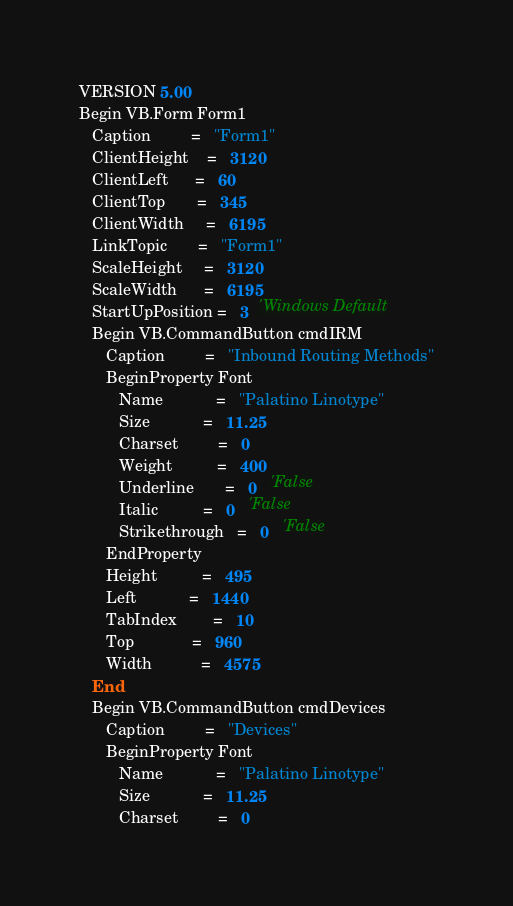<code> <loc_0><loc_0><loc_500><loc_500><_VisualBasic_>VERSION 5.00
Begin VB.Form Form1 
   Caption         =   "Form1"
   ClientHeight    =   3120
   ClientLeft      =   60
   ClientTop       =   345
   ClientWidth     =   6195
   LinkTopic       =   "Form1"
   ScaleHeight     =   3120
   ScaleWidth      =   6195
   StartUpPosition =   3  'Windows Default
   Begin VB.CommandButton cmdIRM 
      Caption         =   "Inbound Routing Methods"
      BeginProperty Font 
         Name            =   "Palatino Linotype"
         Size            =   11.25
         Charset         =   0
         Weight          =   400
         Underline       =   0   'False
         Italic          =   0   'False
         Strikethrough   =   0   'False
      EndProperty
      Height          =   495
      Left            =   1440
      TabIndex        =   10
      Top             =   960
      Width           =   4575
   End
   Begin VB.CommandButton cmdDevices 
      Caption         =   "Devices"
      BeginProperty Font 
         Name            =   "Palatino Linotype"
         Size            =   11.25
         Charset         =   0</code> 